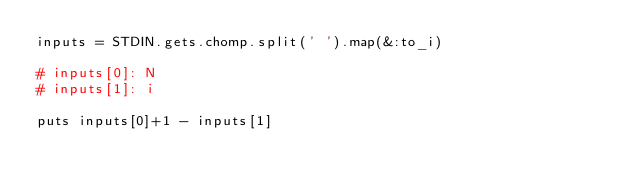<code> <loc_0><loc_0><loc_500><loc_500><_Ruby_>inputs = STDIN.gets.chomp.split(' ').map(&:to_i)

# inputs[0]: N
# inputs[1]: i

puts inputs[0]+1 - inputs[1]</code> 